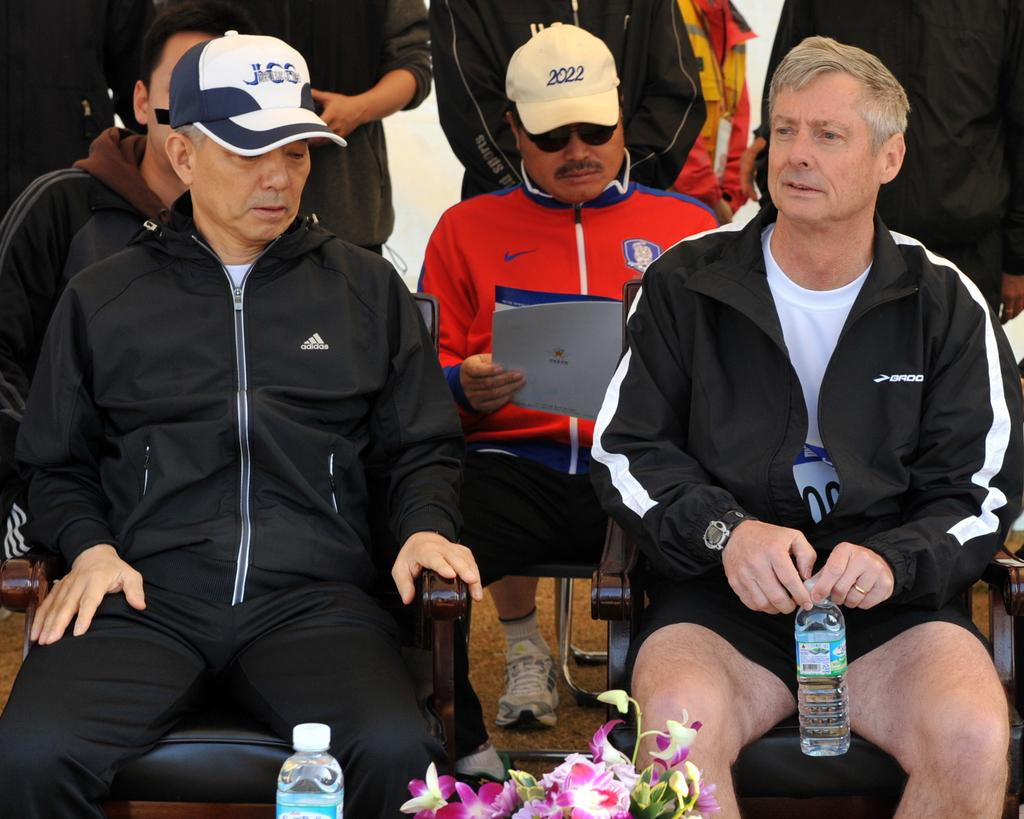<image>
Share a concise interpretation of the image provided. a man in the center reading a program with a hat saying 2022 